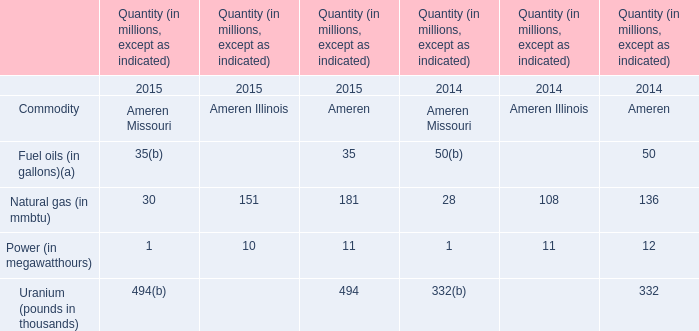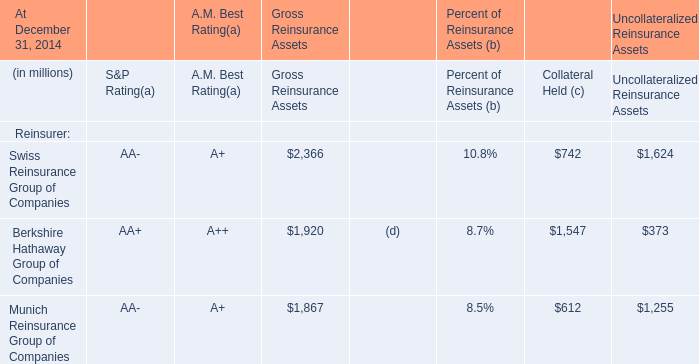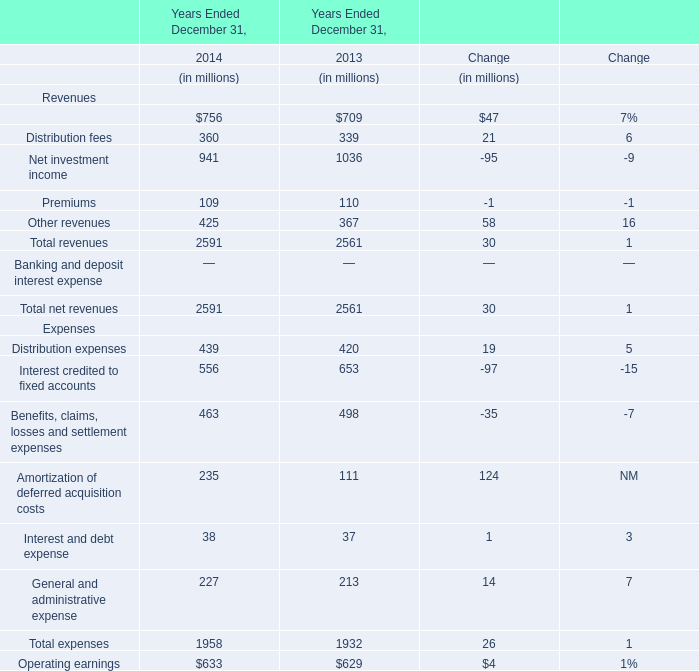What is the amount of Distribution fees and Net investment income in the year with the most Distribution fees (in million) 
Computations: (360 + 941)
Answer: 1301.0. 